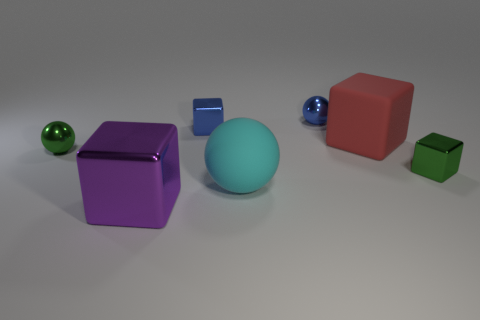Add 3 small blue metal spheres. How many objects exist? 10 Subtract all balls. How many objects are left? 4 Add 7 purple blocks. How many purple blocks are left? 8 Add 7 cyan rubber objects. How many cyan rubber objects exist? 8 Subtract 0 gray spheres. How many objects are left? 7 Subtract all green metallic balls. Subtract all big red matte things. How many objects are left? 5 